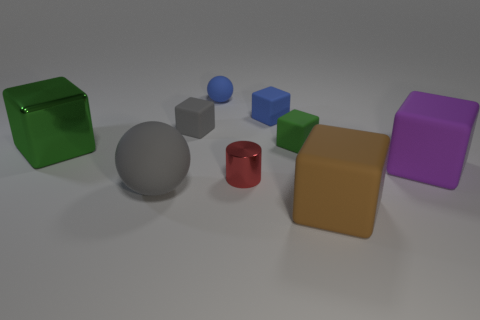Subtract all brown matte cubes. How many cubes are left? 5 Add 1 purple rubber things. How many objects exist? 10 Subtract 1 cubes. How many cubes are left? 5 Subtract all brown balls. How many green blocks are left? 2 Subtract all brown blocks. How many blocks are left? 5 Subtract all blocks. How many objects are left? 3 Subtract all purple blocks. Subtract all green cylinders. How many blocks are left? 5 Subtract all big gray things. Subtract all big green metallic things. How many objects are left? 7 Add 9 gray matte cubes. How many gray matte cubes are left? 10 Add 4 large gray rubber spheres. How many large gray rubber spheres exist? 5 